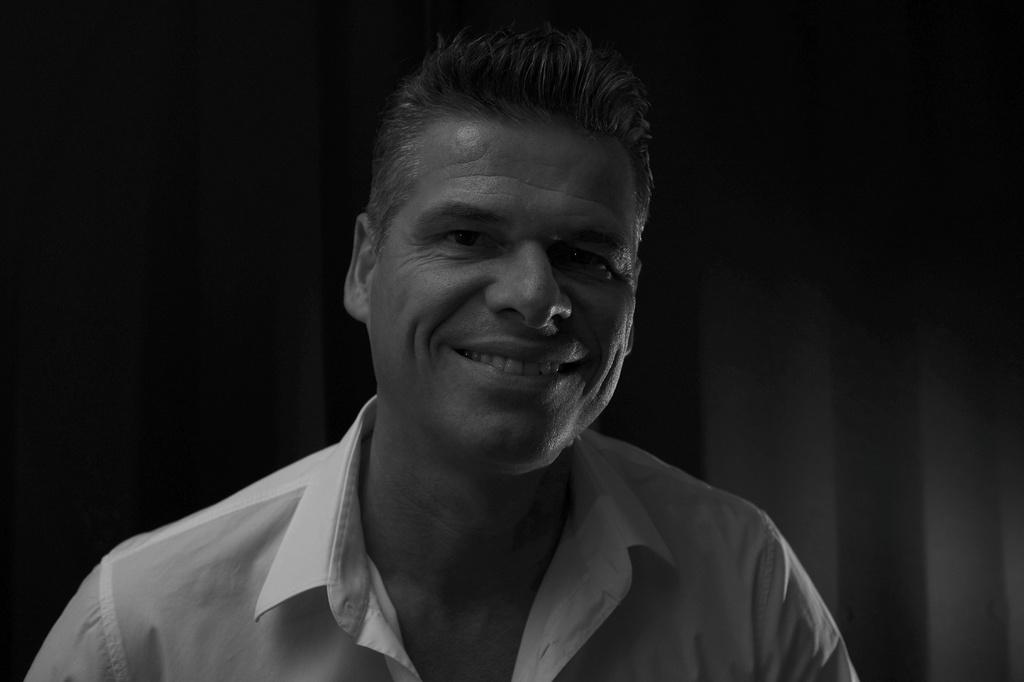What is present in the image? There is a person in the image. How is the person's expression in the image? The person is smiling. What type of jam is being spread on the trees in the image? There are no trees or jam present in the image; it only features a person who is smiling. 